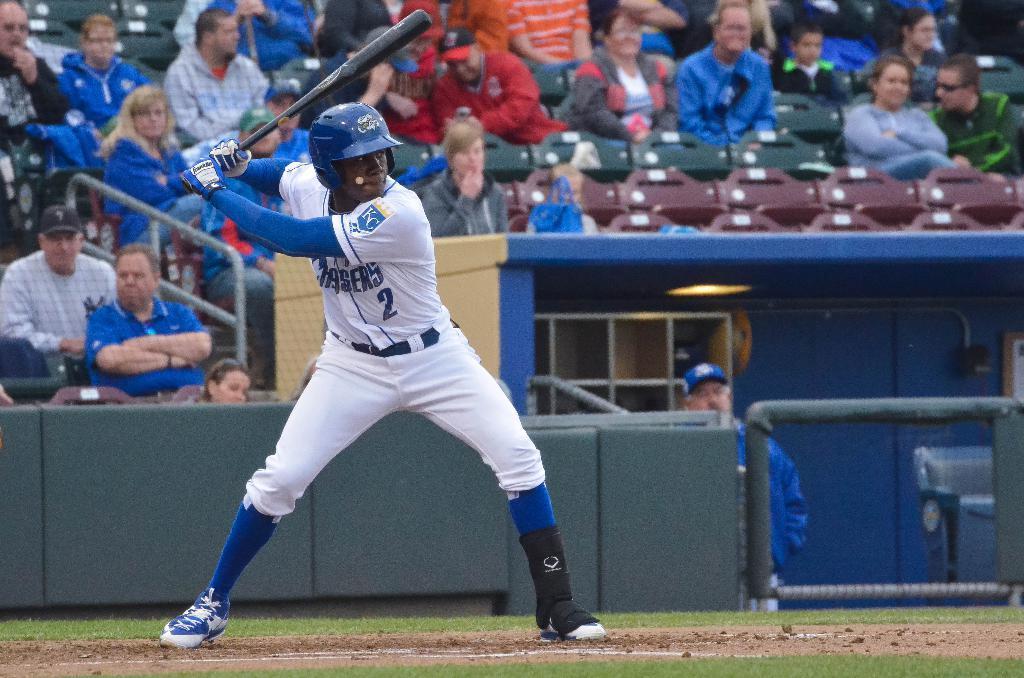In one or two sentences, can you explain what this image depicts? In this picture I can see there is a man standing and he is wearing a white jersey and a white pant. He is holding a baseball bat and there are few people sitting in the backdrop and there is a fence and there are few empty chairs. 